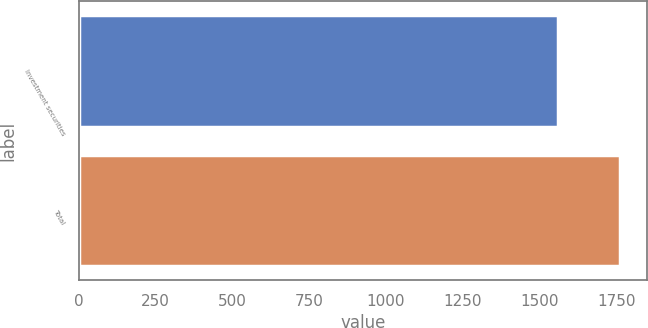<chart> <loc_0><loc_0><loc_500><loc_500><bar_chart><fcel>Investment securities<fcel>Total<nl><fcel>1561<fcel>1761<nl></chart> 